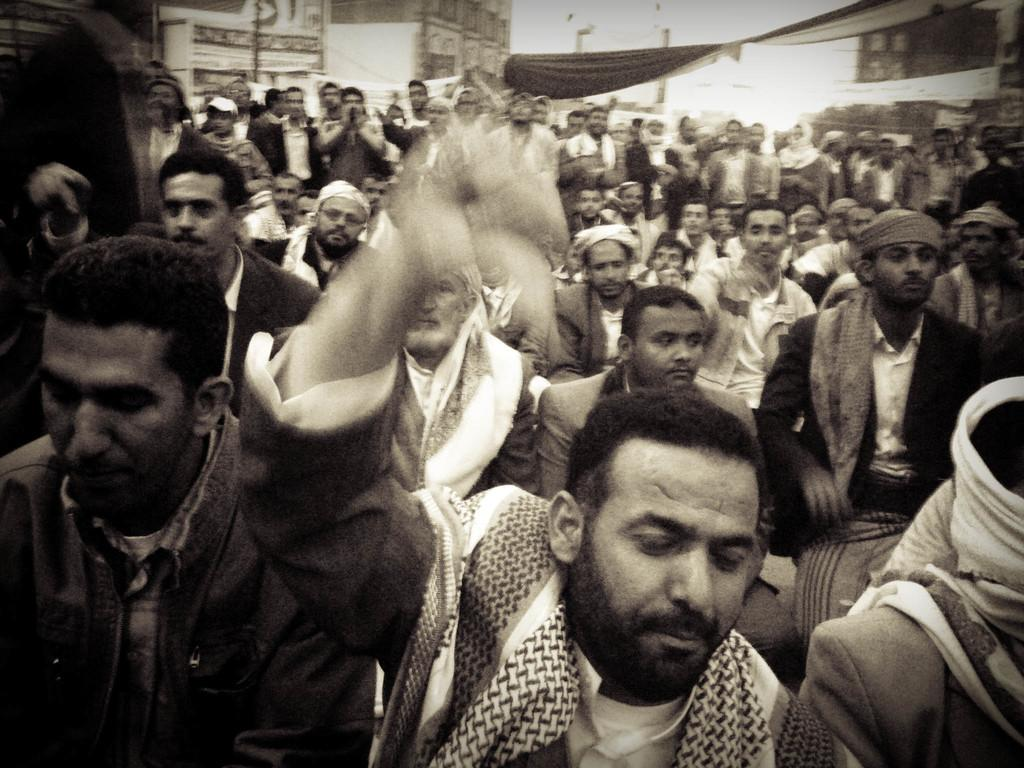What is the color scheme of the image? The image is black and white. What can be seen in the image? There are people in the image. Where is the monkey sitting in the image? There is no monkey present in the image. What type of unit is being measured in the image? There is no measurement or unit being depicted in the image. 